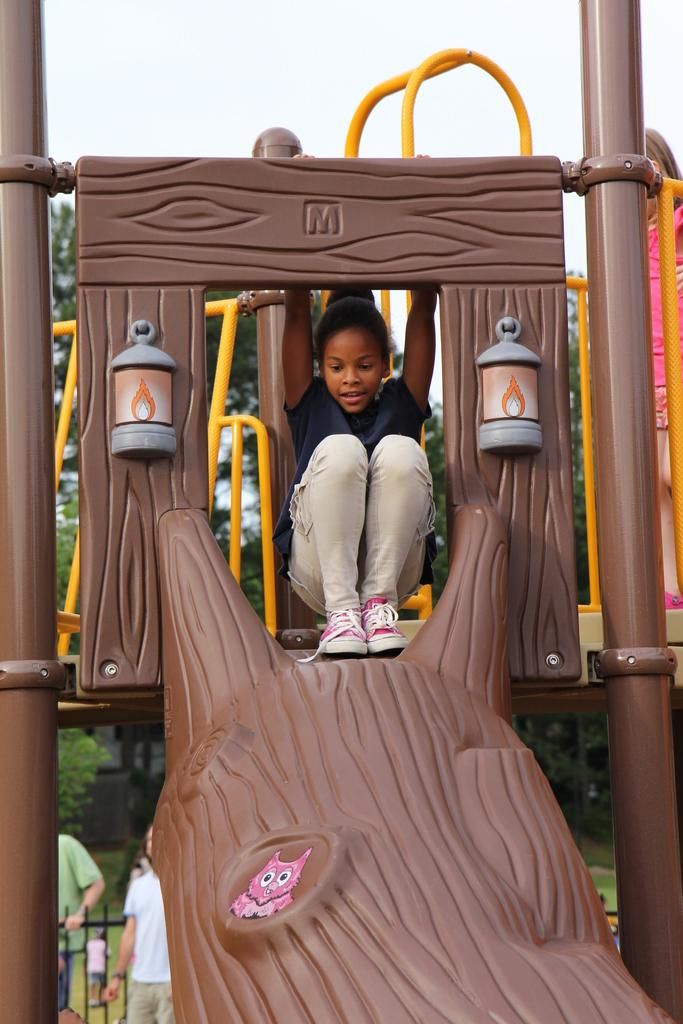What is the girl sitting on in the image? The girl is sitting on a slider. What can be seen behind the girl? There are trees behind the girl. What is the position of the people in the image? People are standing in front of a fence. What is visible in the background of the image? The sky is visible in the background. What type of tray is being used by the trees in the image? There is no tray present in the image, as the trees are not using any objects. 